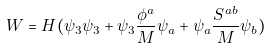Convert formula to latex. <formula><loc_0><loc_0><loc_500><loc_500>W = H ( \psi _ { 3 } \psi _ { 3 } + \psi _ { 3 } \frac { \phi ^ { a } } { M } \psi _ { a } + \psi _ { a } \frac { S ^ { a b } } { M } \psi _ { b } )</formula> 